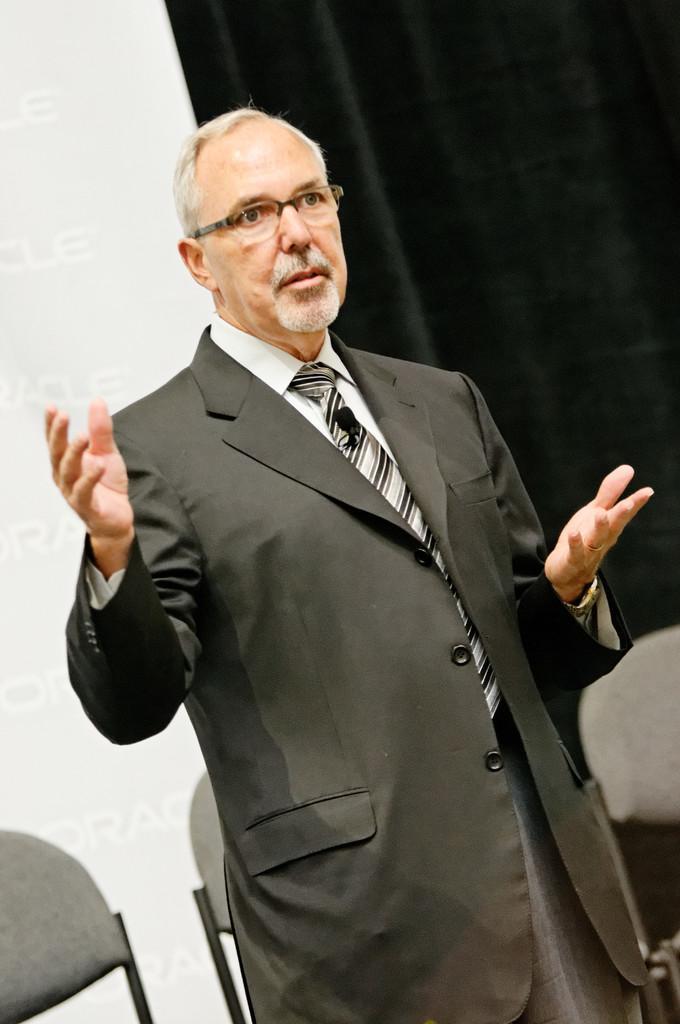How would you summarize this image in a sentence or two? In the picture I can see a person wearing black suit is standing and speaking and there are two chairs behind him and there are some other objects in the background. 